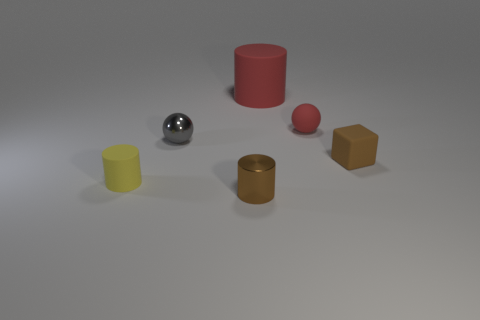Add 3 small green metal cylinders. How many objects exist? 9 Subtract all balls. How many objects are left? 4 Subtract all large things. Subtract all small brown blocks. How many objects are left? 4 Add 6 matte blocks. How many matte blocks are left? 7 Add 5 tiny metallic objects. How many tiny metallic objects exist? 7 Subtract 0 yellow balls. How many objects are left? 6 